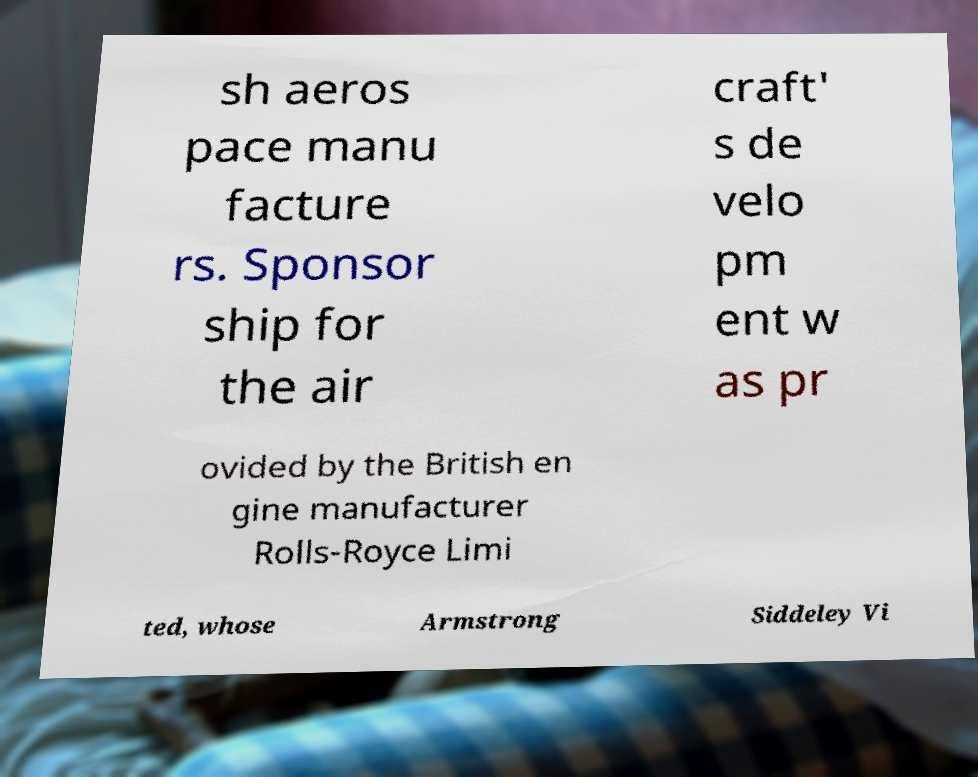Could you assist in decoding the text presented in this image and type it out clearly? sh aeros pace manu facture rs. Sponsor ship for the air craft' s de velo pm ent w as pr ovided by the British en gine manufacturer Rolls-Royce Limi ted, whose Armstrong Siddeley Vi 